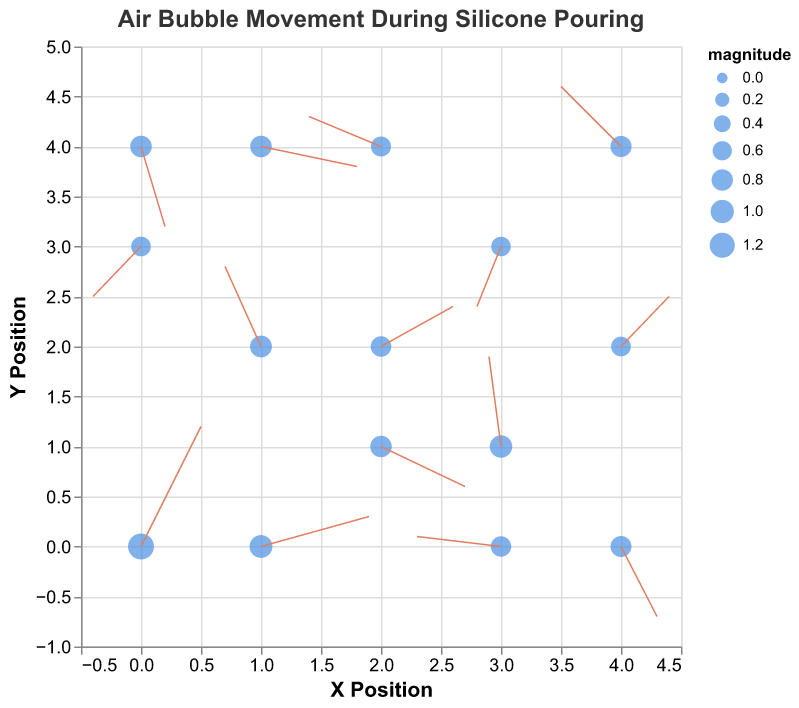What is the title of the figure? The title of the figure is clearly displayed at the top. It reads "Air Bubble Movement During Silicone Pouring".
Answer: Air Bubble Movement During Silicone Pouring How many data points are represented in the plot? By counting the individual points in the plot, we see that there are 15 data points.
Answer: 15 Which data point has the largest magnitude, and what is its value? By examining the size of the points, the largest point corresponds to the data with the largest magnitude. The point at (1, 0) has the largest size, corresponding to a magnitude of 0.95.
Answer: (1, 0), 0.95 Which vector has the fastest upward movement (highest positive v value)? The vector with the highest positive v value points the steepest upwards. The vector at (0, 0) has a v value of 1.2, which is the highest.
Answer: (0, 0) What is the average magnitude of the vectors in the plot? To find the average magnitude, sum up all the magnitudes and divide by the number of vectors. The sum of magnitudes is 1.3 + 0.85 + 0.81 + 0.63 + 0.64 + 0.67 + 0.82 + 0.91 + 0.76 + 0.64 + 0.72 + 0.78 + 0.82 + 0.71 + 0.95 = 12.61. There are 15 vectors, so 12.61 / 15 = 0.84 (rounded).
Answer: 0.84 Which vector appears to be the longest in the plot, and at what coordinates is it located? The length of vectors is represented by their magnitude. The vector at (0, 0) has the longest vector with a magnitude of 1.3.
Answer: (0, 0) Are there any vectors pointing in the downward direction? If so, identify one such vector's starting position. Vectors pointing downward will have a negative v value. For example, the vector at (2, 1) is pointing downward with a v value of -0.4.
Answer: (2, 1) Which data point represents the smallest vector in terms of magnitude, and what is its value? The smallest vector corresponds to the smallest magnitude. The vector at (3, 3) has the smallest magnitude of 0.63.
Answer: (3, 3), 0.63 Compare the vectors at coordinates (2, 2) and (4, 4). Which one has the larger magnitude? By comparing the magnitudes of the two vectors: (2, 2) has a magnitude of 0.72, and (4, 4) has a magnitude of 0.78. The vector at (4, 4) has the larger magnitude.
Answer: (4, 4) How many vectors are pointing at least partially to the left (negative u value)? To find the vectors pointing at least partially left, count the vectors with a negative u value: at (1, 2), (3, 3), (2, 4), (3, 1), (0, 3), (3, 0). There are 6 such vectors.
Answer: 6 